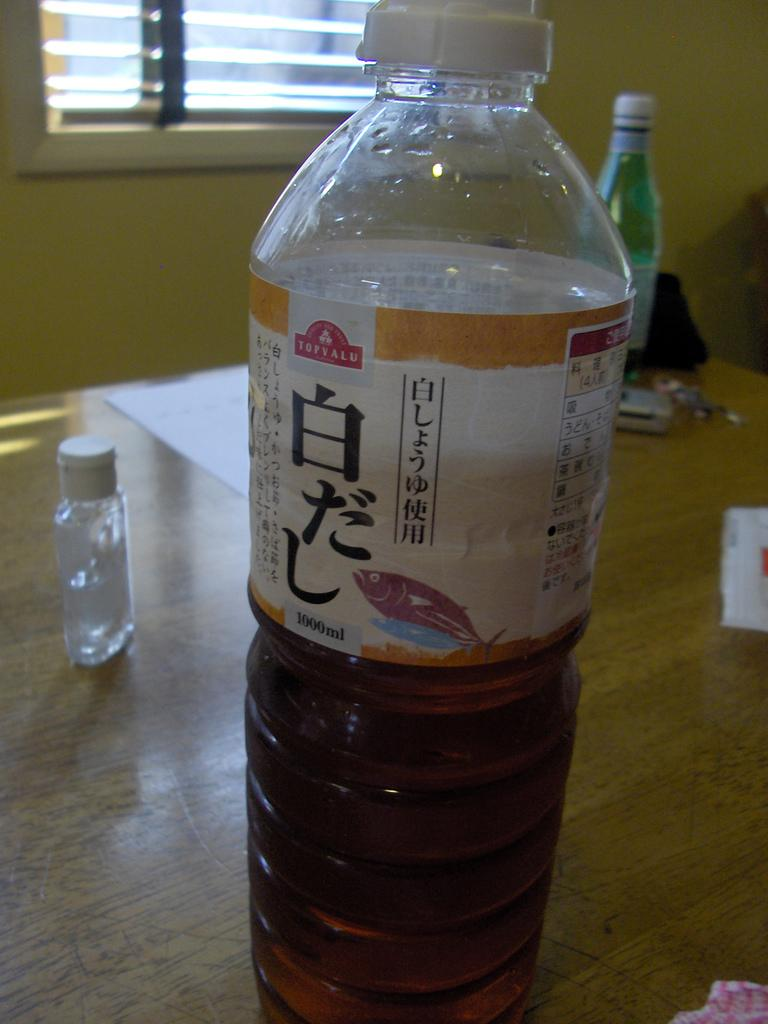<image>
Share a concise interpretation of the image provided. The liquid contained in this plastic bottle is top valu. 